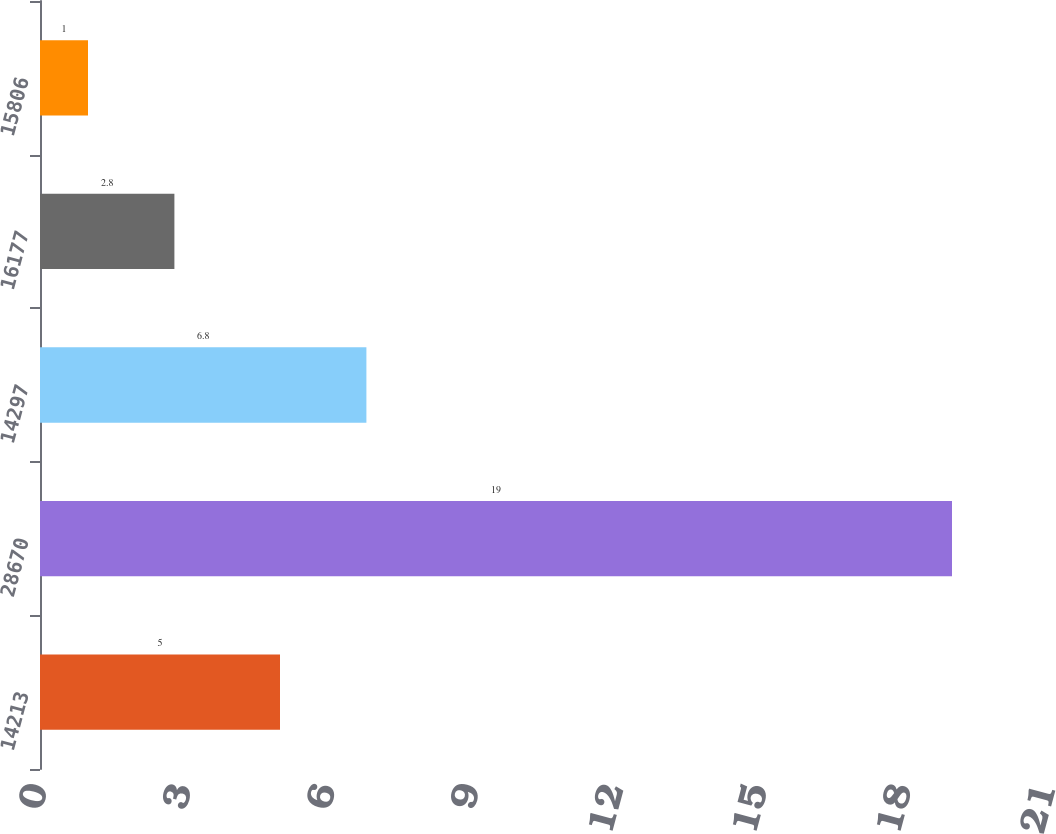<chart> <loc_0><loc_0><loc_500><loc_500><bar_chart><fcel>14213<fcel>28670<fcel>14297<fcel>16177<fcel>15806<nl><fcel>5<fcel>19<fcel>6.8<fcel>2.8<fcel>1<nl></chart> 